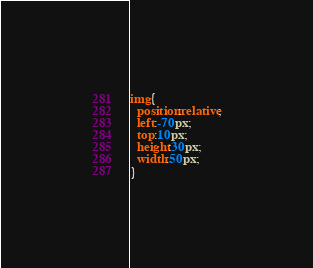Convert code to text. <code><loc_0><loc_0><loc_500><loc_500><_CSS_>img{
  position:relative;
  left:-70px;
  top:10px;
  height:30px;
  width:50px;
}
</code> 